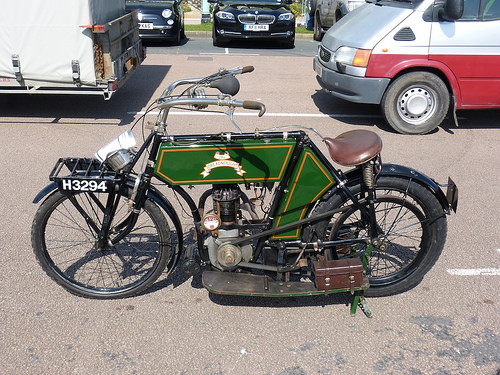<image>
Is the car next to the car? Yes. The car is positioned adjacent to the car, located nearby in the same general area. Is the electric bike next to the road? No. The electric bike is not positioned next to the road. They are located in different areas of the scene. 